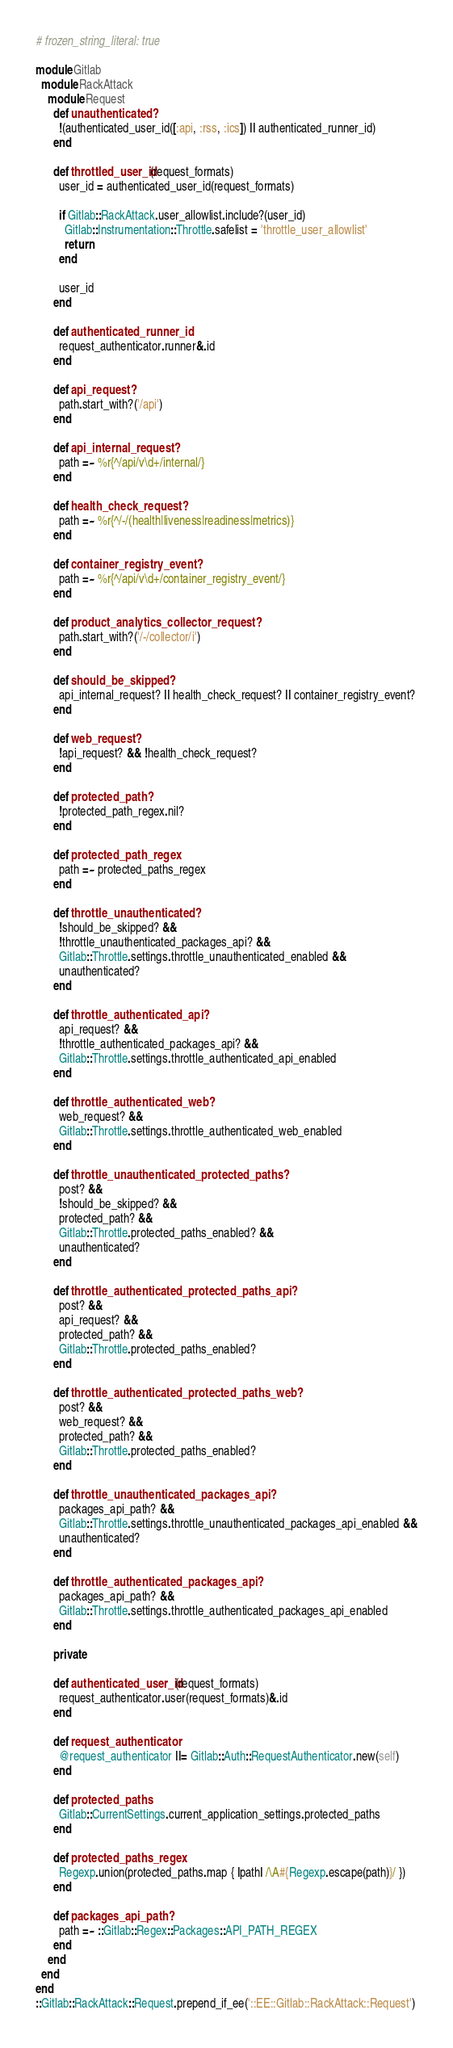<code> <loc_0><loc_0><loc_500><loc_500><_Ruby_># frozen_string_literal: true

module Gitlab
  module RackAttack
    module Request
      def unauthenticated?
        !(authenticated_user_id([:api, :rss, :ics]) || authenticated_runner_id)
      end

      def throttled_user_id(request_formats)
        user_id = authenticated_user_id(request_formats)

        if Gitlab::RackAttack.user_allowlist.include?(user_id)
          Gitlab::Instrumentation::Throttle.safelist = 'throttle_user_allowlist'
          return
        end

        user_id
      end

      def authenticated_runner_id
        request_authenticator.runner&.id
      end

      def api_request?
        path.start_with?('/api')
      end

      def api_internal_request?
        path =~ %r{^/api/v\d+/internal/}
      end

      def health_check_request?
        path =~ %r{^/-/(health|liveness|readiness|metrics)}
      end

      def container_registry_event?
        path =~ %r{^/api/v\d+/container_registry_event/}
      end

      def product_analytics_collector_request?
        path.start_with?('/-/collector/i')
      end

      def should_be_skipped?
        api_internal_request? || health_check_request? || container_registry_event?
      end

      def web_request?
        !api_request? && !health_check_request?
      end

      def protected_path?
        !protected_path_regex.nil?
      end

      def protected_path_regex
        path =~ protected_paths_regex
      end

      def throttle_unauthenticated?
        !should_be_skipped? &&
        !throttle_unauthenticated_packages_api? &&
        Gitlab::Throttle.settings.throttle_unauthenticated_enabled &&
        unauthenticated?
      end

      def throttle_authenticated_api?
        api_request? &&
        !throttle_authenticated_packages_api? &&
        Gitlab::Throttle.settings.throttle_authenticated_api_enabled
      end

      def throttle_authenticated_web?
        web_request? &&
        Gitlab::Throttle.settings.throttle_authenticated_web_enabled
      end

      def throttle_unauthenticated_protected_paths?
        post? &&
        !should_be_skipped? &&
        protected_path? &&
        Gitlab::Throttle.protected_paths_enabled? &&
        unauthenticated?
      end

      def throttle_authenticated_protected_paths_api?
        post? &&
        api_request? &&
        protected_path? &&
        Gitlab::Throttle.protected_paths_enabled?
      end

      def throttle_authenticated_protected_paths_web?
        post? &&
        web_request? &&
        protected_path? &&
        Gitlab::Throttle.protected_paths_enabled?
      end

      def throttle_unauthenticated_packages_api?
        packages_api_path? &&
        Gitlab::Throttle.settings.throttle_unauthenticated_packages_api_enabled &&
        unauthenticated?
      end

      def throttle_authenticated_packages_api?
        packages_api_path? &&
        Gitlab::Throttle.settings.throttle_authenticated_packages_api_enabled
      end

      private

      def authenticated_user_id(request_formats)
        request_authenticator.user(request_formats)&.id
      end

      def request_authenticator
        @request_authenticator ||= Gitlab::Auth::RequestAuthenticator.new(self)
      end

      def protected_paths
        Gitlab::CurrentSettings.current_application_settings.protected_paths
      end

      def protected_paths_regex
        Regexp.union(protected_paths.map { |path| /\A#{Regexp.escape(path)}/ })
      end

      def packages_api_path?
        path =~ ::Gitlab::Regex::Packages::API_PATH_REGEX
      end
    end
  end
end
::Gitlab::RackAttack::Request.prepend_if_ee('::EE::Gitlab::RackAttack::Request')
</code> 